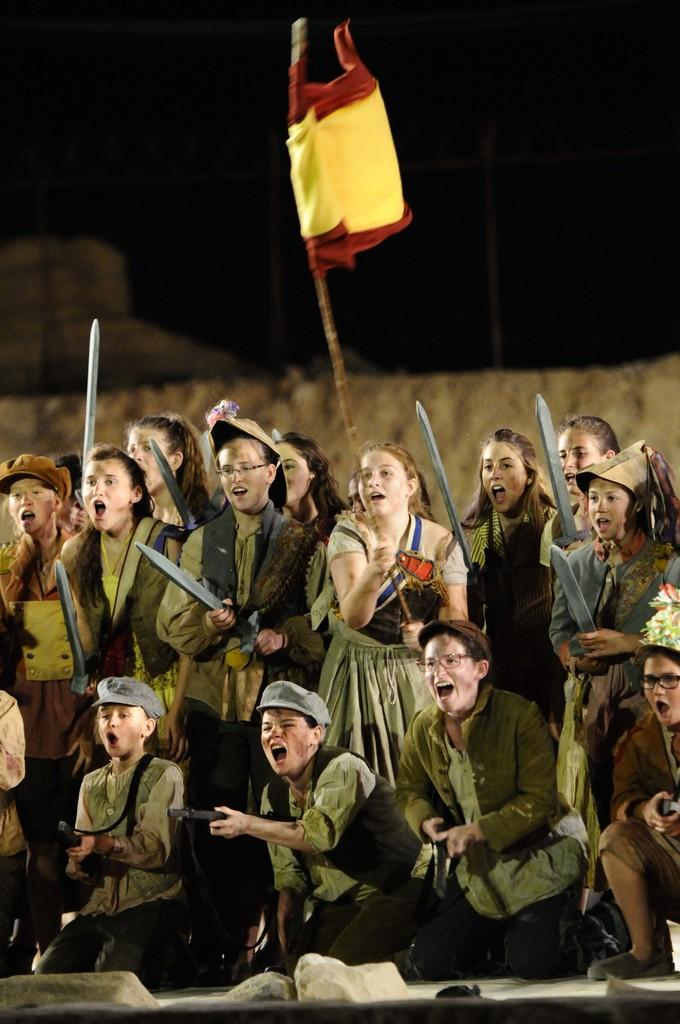How many people are in the image? There are people in the image, but the exact number is not specified. What are the people doing in the image? Some people are sitting, while others are standing, and they are holding swords. What is the color of the background in the image? The background of the image is dark. What type of sugar is being used to zip up the recess in the image? There is no mention of sugar, zippers, or recesses in the image. The image features people holding swords with a dark background. 